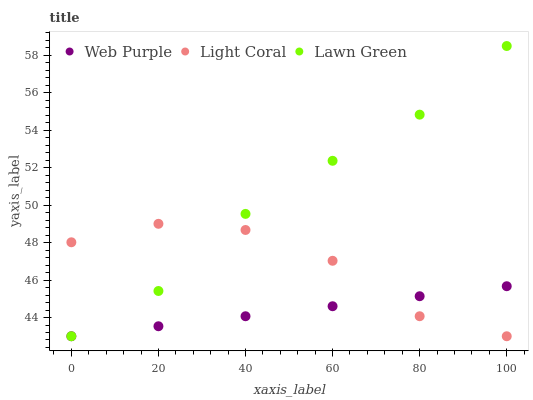Does Web Purple have the minimum area under the curve?
Answer yes or no. Yes. Does Lawn Green have the maximum area under the curve?
Answer yes or no. Yes. Does Lawn Green have the minimum area under the curve?
Answer yes or no. No. Does Web Purple have the maximum area under the curve?
Answer yes or no. No. Is Web Purple the smoothest?
Answer yes or no. Yes. Is Light Coral the roughest?
Answer yes or no. Yes. Is Lawn Green the smoothest?
Answer yes or no. No. Is Lawn Green the roughest?
Answer yes or no. No. Does Light Coral have the lowest value?
Answer yes or no. Yes. Does Lawn Green have the highest value?
Answer yes or no. Yes. Does Web Purple have the highest value?
Answer yes or no. No. Does Light Coral intersect Web Purple?
Answer yes or no. Yes. Is Light Coral less than Web Purple?
Answer yes or no. No. Is Light Coral greater than Web Purple?
Answer yes or no. No. 